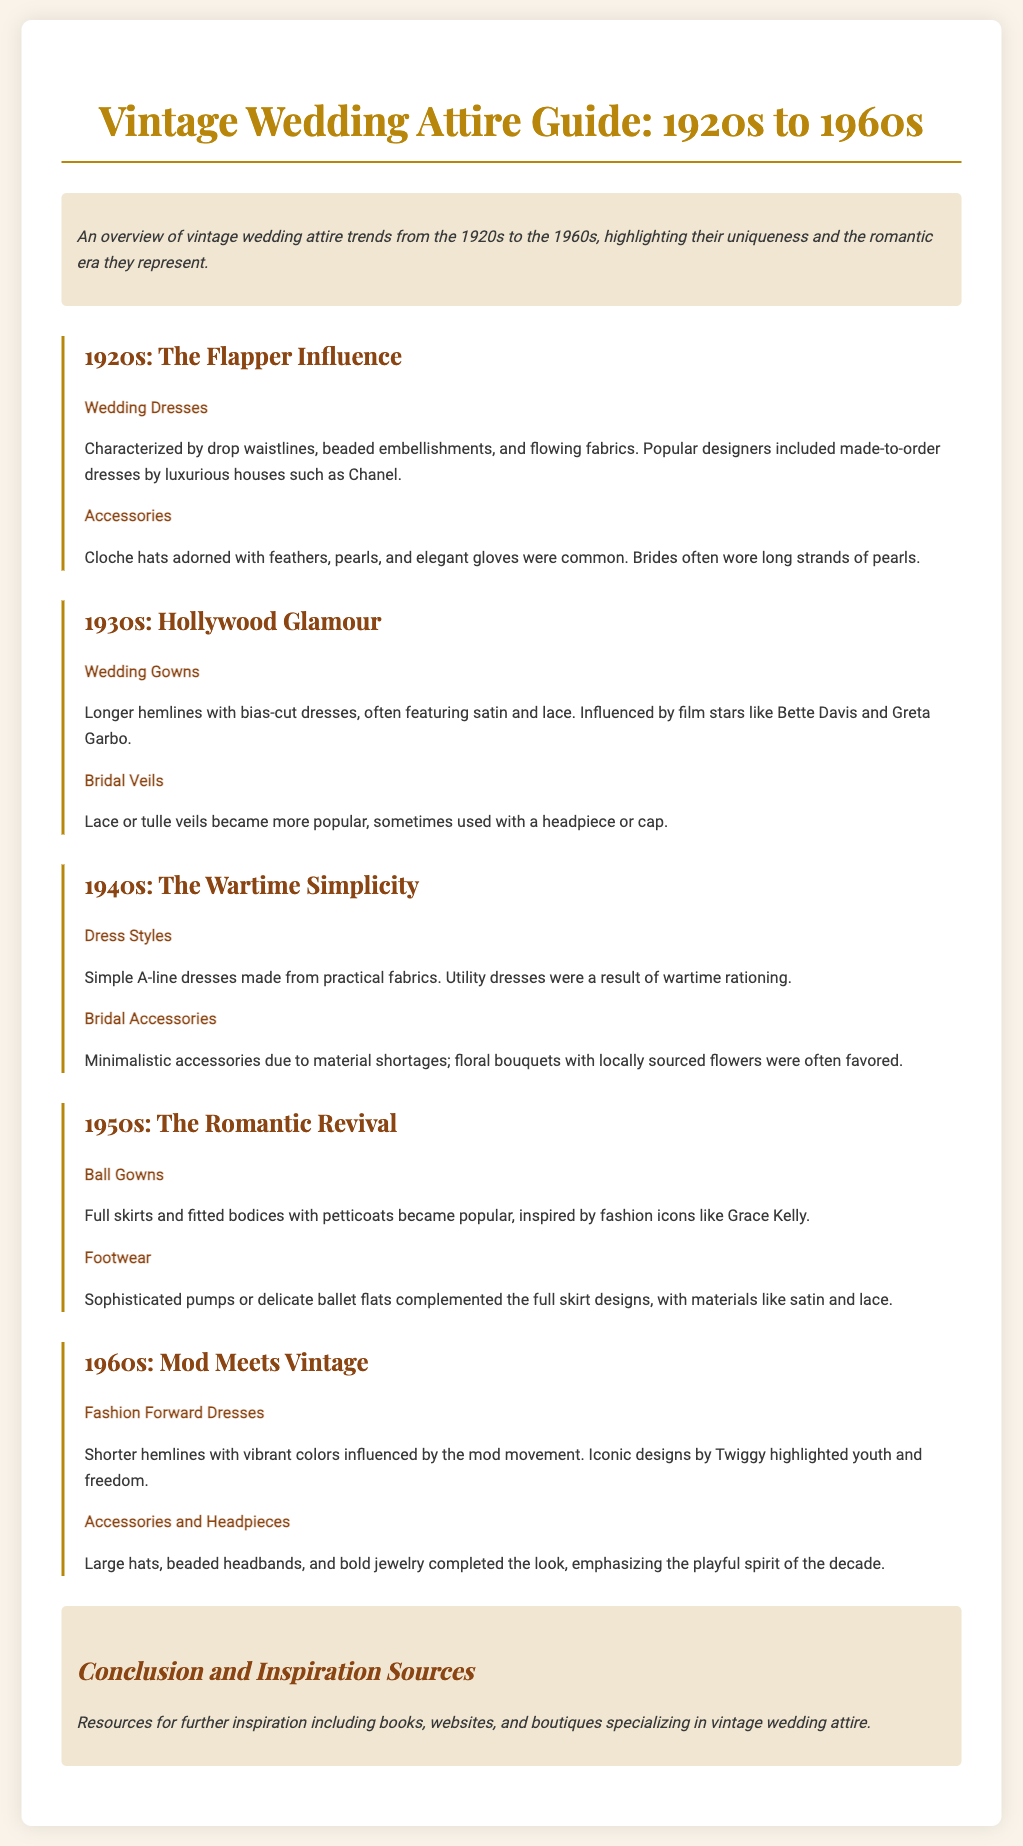What characterized wedding dresses in the 1920s? Wedding dresses in the 1920s were characterized by drop waistlines, beaded embellishments, and flowing fabrics.
Answer: Drop waistlines, beaded embellishments, flowing fabrics Who were the popular designers in the 1920s? Popular designers in the 1920s included made-to-order dresses by luxurious houses such as Chanel.
Answer: Chanel What type of veils became popular in the 1930s? Lace or tulle veils became more popular in the 1930s, sometimes used with a headpiece or cap.
Answer: Lace or tulle veils What style of dresses were common in the 1940s? Simple A-line dresses were common in the 1940s, made from practical fabrics.
Answer: Simple A-line dresses What influenced the ball gowns in the 1950s? Ball gowns in the 1950s were inspired by fashion icons like Grace Kelly.
Answer: Grace Kelly Which decade introduced shorter hemlines and vibrant colors? The 1960s introduced shorter hemlines and vibrant colors influenced by the mod movement.
Answer: 1960s What type of materials were popular for footwear in the 1950s? Sophisticated pumps or delicate ballet flats made from satin and lace were popular for footwear in the 1950s.
Answer: Satin and lace What was favored for bridal accessories in the 1940s? Minimalistic accessories due to material shortages were favored for bridal accessories in the 1940s.
Answer: Minimalistic accessories What era is known for the Flapper influence? The 1920s is known for the Flapper influence in vintage wedding attire.
Answer: 1920s 